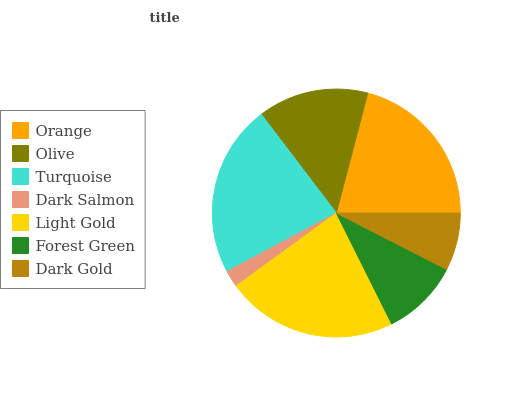Is Dark Salmon the minimum?
Answer yes or no. Yes. Is Turquoise the maximum?
Answer yes or no. Yes. Is Olive the minimum?
Answer yes or no. No. Is Olive the maximum?
Answer yes or no. No. Is Orange greater than Olive?
Answer yes or no. Yes. Is Olive less than Orange?
Answer yes or no. Yes. Is Olive greater than Orange?
Answer yes or no. No. Is Orange less than Olive?
Answer yes or no. No. Is Olive the high median?
Answer yes or no. Yes. Is Olive the low median?
Answer yes or no. Yes. Is Forest Green the high median?
Answer yes or no. No. Is Light Gold the low median?
Answer yes or no. No. 